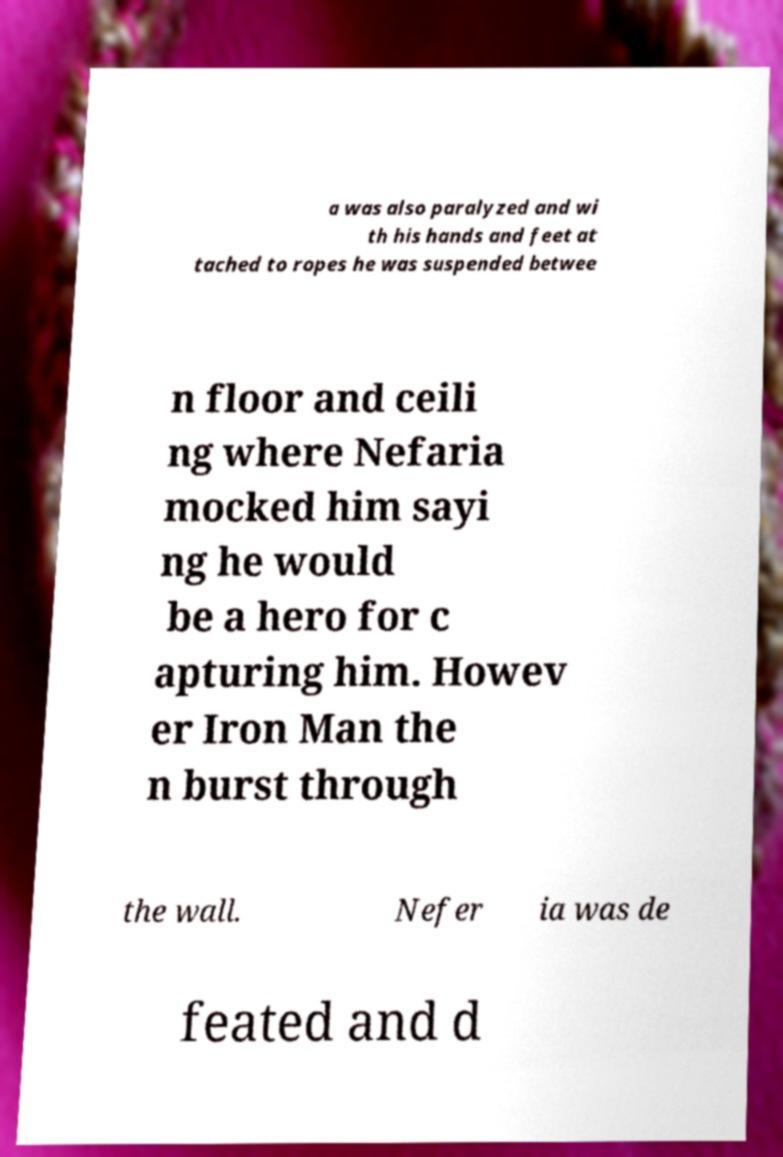For documentation purposes, I need the text within this image transcribed. Could you provide that? a was also paralyzed and wi th his hands and feet at tached to ropes he was suspended betwee n floor and ceili ng where Nefaria mocked him sayi ng he would be a hero for c apturing him. Howev er Iron Man the n burst through the wall. Nefer ia was de feated and d 